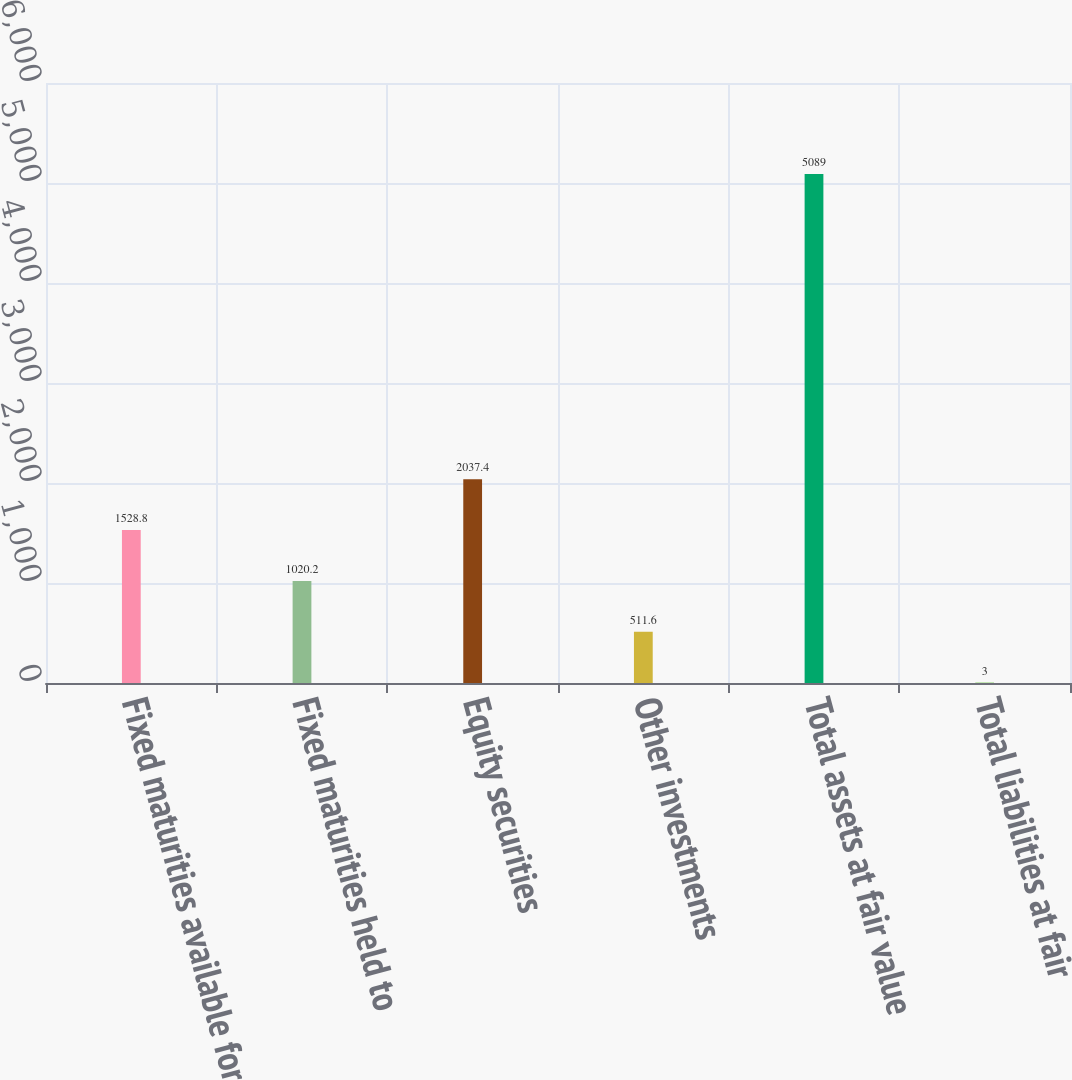Convert chart. <chart><loc_0><loc_0><loc_500><loc_500><bar_chart><fcel>Fixed maturities available for<fcel>Fixed maturities held to<fcel>Equity securities<fcel>Other investments<fcel>Total assets at fair value<fcel>Total liabilities at fair<nl><fcel>1528.8<fcel>1020.2<fcel>2037.4<fcel>511.6<fcel>5089<fcel>3<nl></chart> 